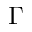<formula> <loc_0><loc_0><loc_500><loc_500>\Gamma</formula> 